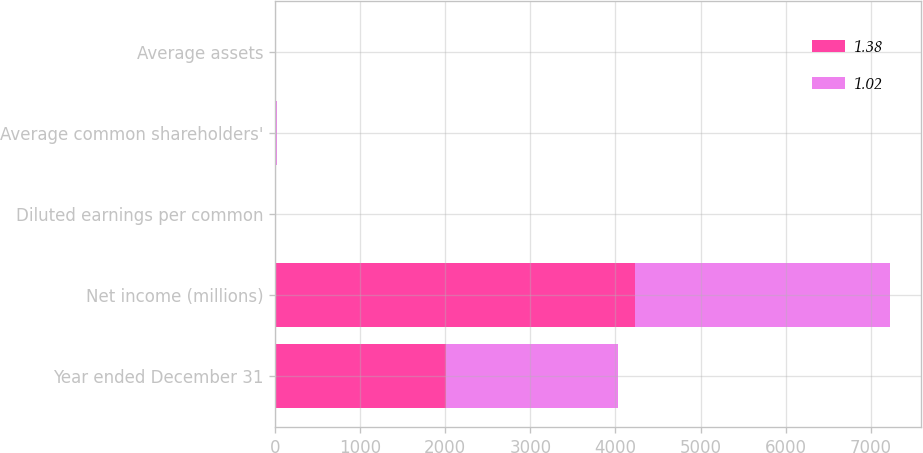<chart> <loc_0><loc_0><loc_500><loc_500><stacked_bar_chart><ecel><fcel>Year ended December 31<fcel>Net income (millions)<fcel>Diluted earnings per common<fcel>Average common shareholders'<fcel>Average assets<nl><fcel>1.38<fcel>2013<fcel>4227<fcel>7.39<fcel>10.88<fcel>1.38<nl><fcel>1.02<fcel>2012<fcel>3001<fcel>5.3<fcel>8.31<fcel>1.02<nl></chart> 